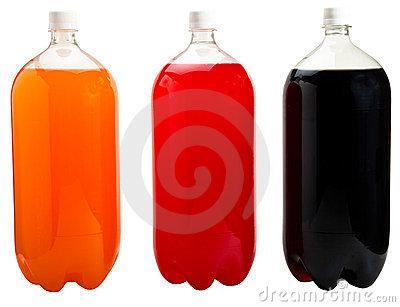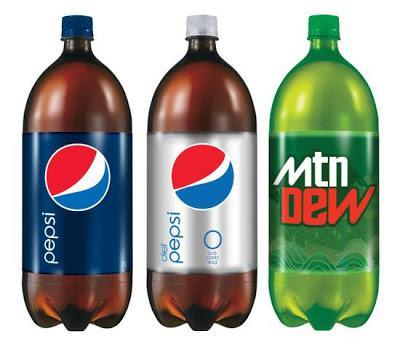The first image is the image on the left, the second image is the image on the right. Examine the images to the left and right. Is the description "The left image shows exactly three bottles of different colored liquids with no labels, and the right image shows three soda bottles with printed labels on the front." accurate? Answer yes or no. Yes. The first image is the image on the left, the second image is the image on the right. Given the left and right images, does the statement "Exactly three bottles of fizzy drink can be seen in each image." hold true? Answer yes or no. Yes. 